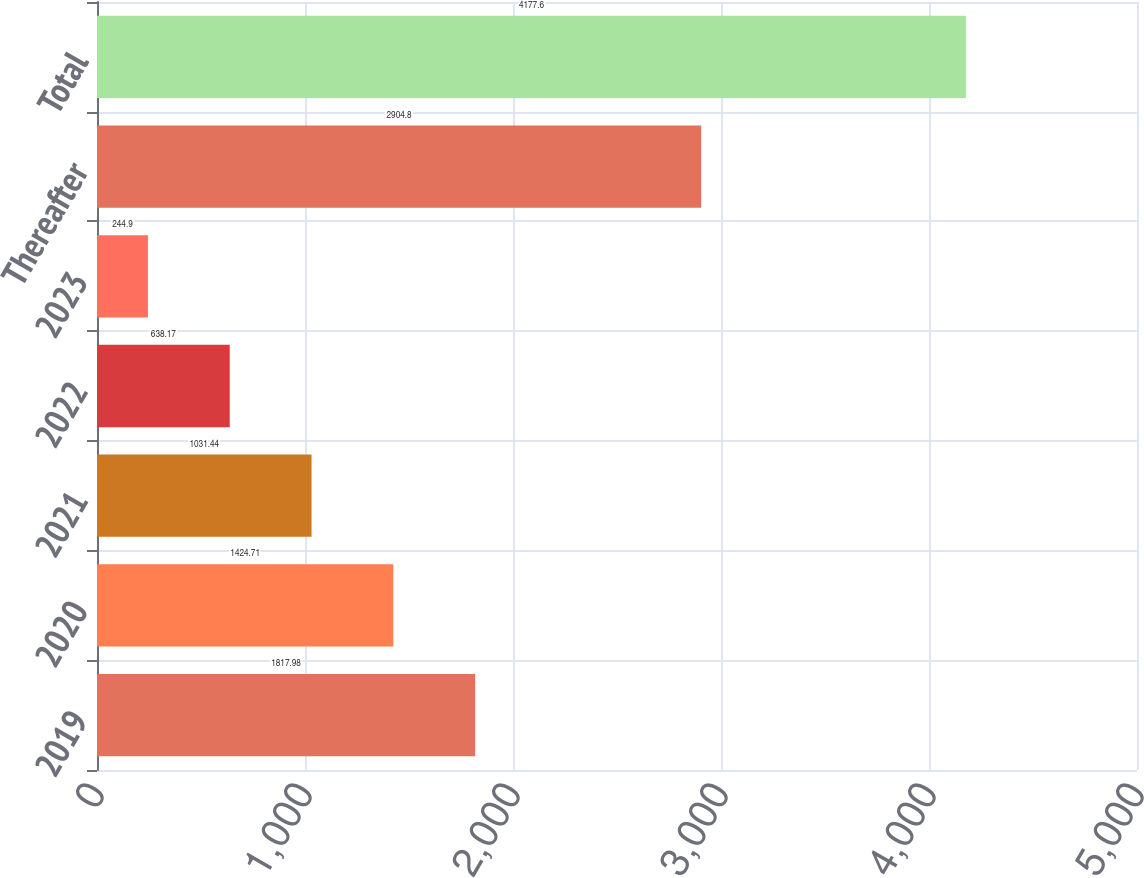Convert chart. <chart><loc_0><loc_0><loc_500><loc_500><bar_chart><fcel>2019<fcel>2020<fcel>2021<fcel>2022<fcel>2023<fcel>Thereafter<fcel>Total<nl><fcel>1817.98<fcel>1424.71<fcel>1031.44<fcel>638.17<fcel>244.9<fcel>2904.8<fcel>4177.6<nl></chart> 